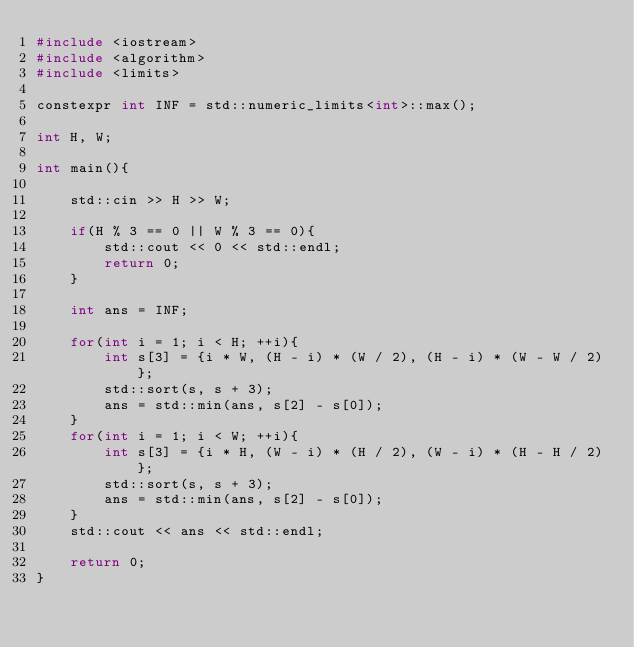Convert code to text. <code><loc_0><loc_0><loc_500><loc_500><_C++_>#include <iostream>
#include <algorithm>
#include <limits>

constexpr int INF = std::numeric_limits<int>::max();

int H, W;

int main(){
	
	std::cin >> H >> W;

	if(H % 3 == 0 || W % 3 == 0){
		std::cout << 0 << std::endl;
		return 0;
	}

	int ans = INF;

	for(int i = 1; i < H; ++i){
		int s[3] = {i * W, (H - i) * (W / 2), (H - i) * (W - W / 2)};
		std::sort(s, s + 3);
		ans = std::min(ans, s[2] - s[0]);
	}
	for(int i = 1; i < W; ++i){
		int s[3] = {i * H, (W - i) * (H / 2), (W - i) * (H - H / 2)};
		std::sort(s, s + 3);
		ans = std::min(ans, s[2] - s[0]);
	}
	std::cout << ans << std::endl;

	return 0;
}
</code> 